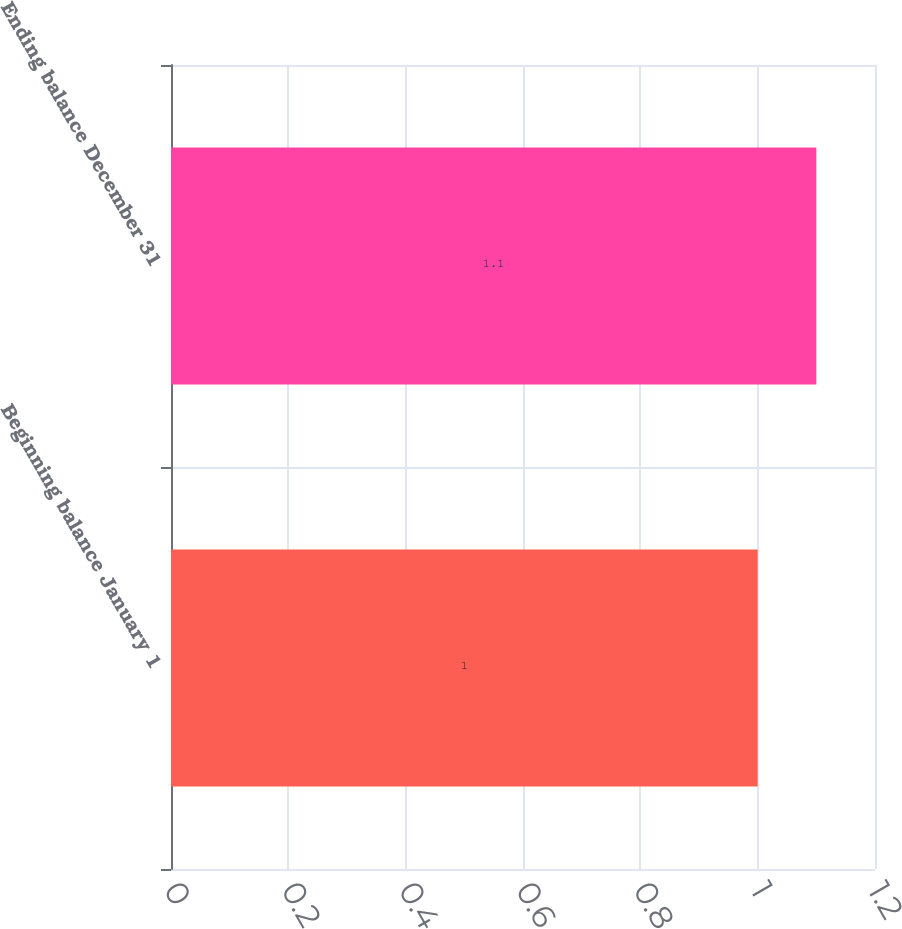Convert chart. <chart><loc_0><loc_0><loc_500><loc_500><bar_chart><fcel>Beginning balance January 1<fcel>Ending balance December 31<nl><fcel>1<fcel>1.1<nl></chart> 